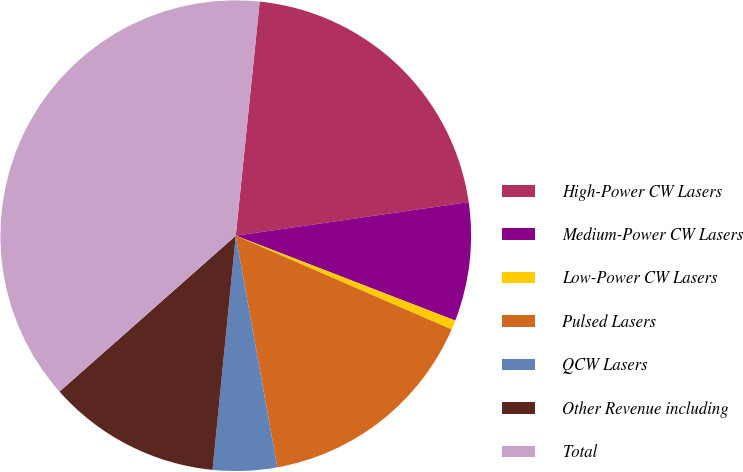Convert chart. <chart><loc_0><loc_0><loc_500><loc_500><pie_chart><fcel>High-Power CW Lasers<fcel>Medium-Power CW Lasers<fcel>Low-Power CW Lasers<fcel>Pulsed Lasers<fcel>QCW Lasers<fcel>Other Revenue including<fcel>Total<nl><fcel>21.1%<fcel>8.15%<fcel>0.65%<fcel>15.65%<fcel>4.4%<fcel>11.9%<fcel>38.15%<nl></chart> 